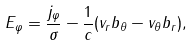<formula> <loc_0><loc_0><loc_500><loc_500>E _ { \varphi } = \frac { j _ { \varphi } } { \sigma } - \frac { 1 } { c } ( v _ { r } b _ { \theta } - v _ { \theta } b _ { r } ) ,</formula> 